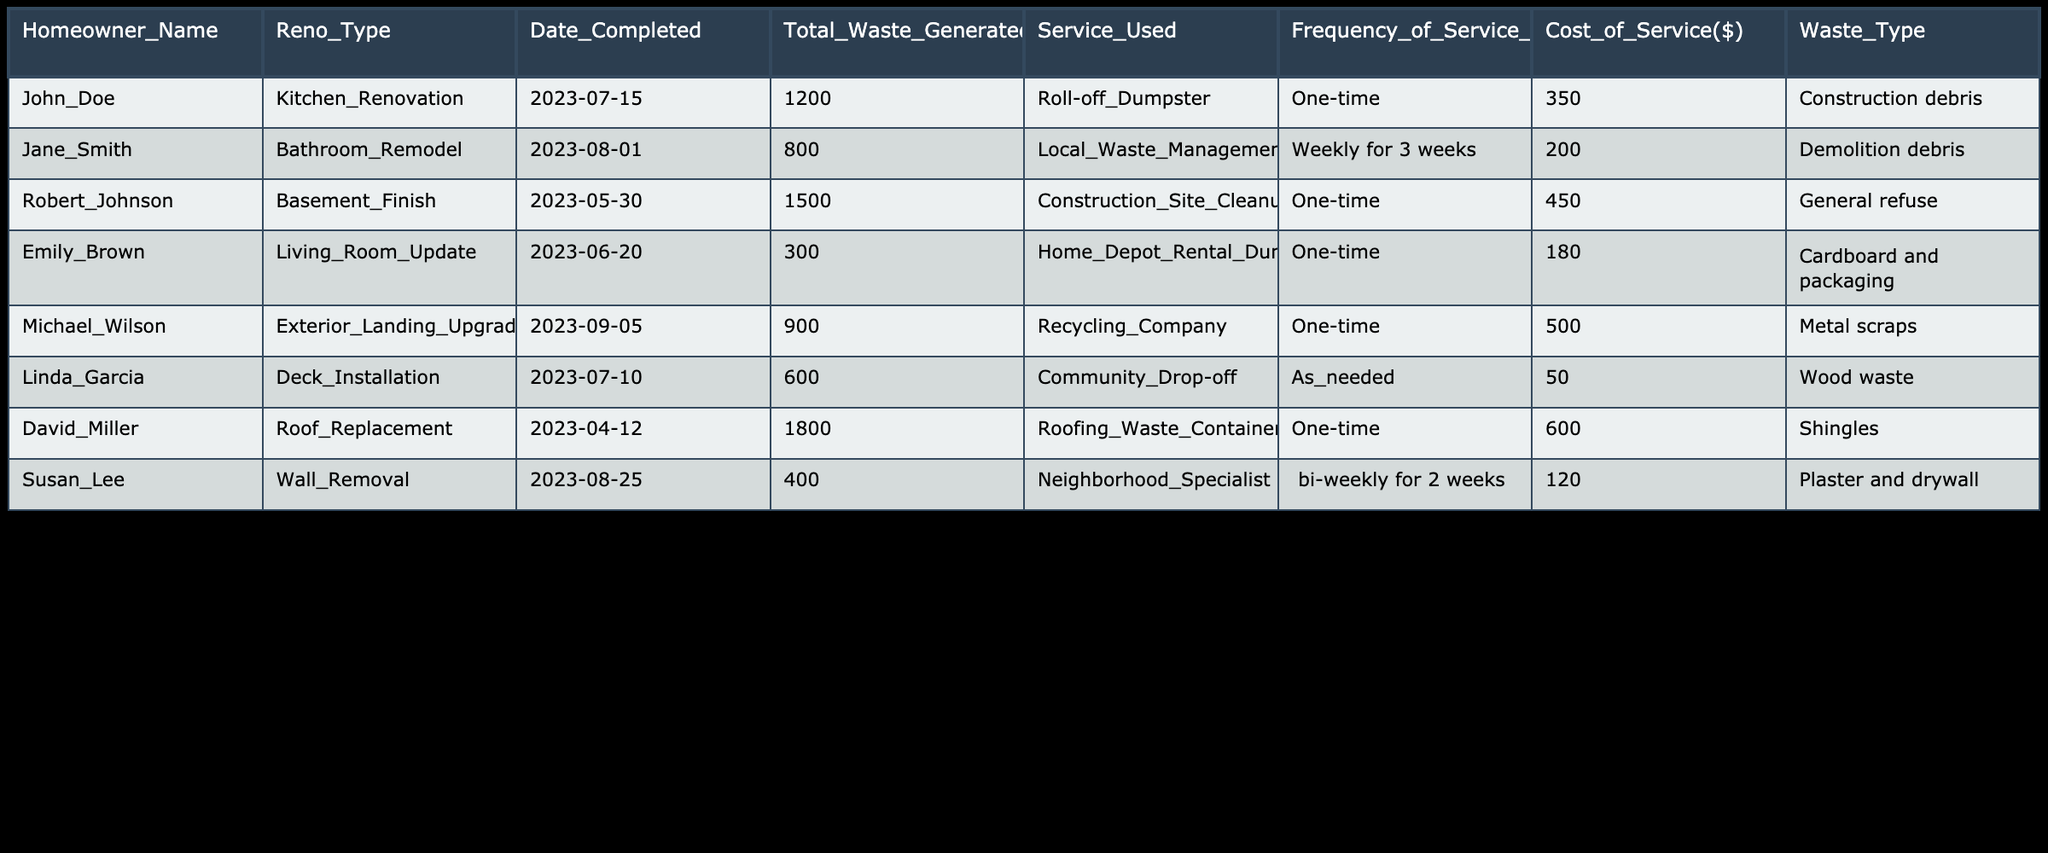What was the total waste generated by Michael Wilson? The table shows that Michael Wilson, who completed an Exterior Landing Upgrade, generated a total waste of 900 kg. This value can be directly located in the 'Total Waste Generated(kg)' column corresponding to Michael Wilson's row.
Answer: 900 kg How many homeowners utilized a one-time waste management service? By reviewing the 'Service Used' column, four homeowners (John Doe, Robert Johnson, Emily Brown, David Miller, and Michael Wilson) used a one-time service. They are indicated clearly in the corresponding rows.
Answer: 5 homeowners What is the total cost of services used by homeowners who paid over 400 dollars? The relevant homeowners who paid over 400 dollars are Robert Johnson (450), Michael Wilson (500), and David Miller (600). Summing these costs yields 450 + 500 + 600 = 1550 dollars.
Answer: 1550 dollars Did Susan Lee use a service more than once? Examining the 'Frequency of Service Used' column, it displays that Susan Lee used her service bi-weekly for two weeks, indicating that this service was utilized more than once.
Answer: Yes What type of waste management service did Linda Garcia use and how often? Linda Garcia used a Community Drop-off service on an as-needed basis, as indicated in the 'Service Used' and 'Frequency of Service Used' columns of her respective row.
Answer: Community Drop-off, as needed What is the average waste generated by homeowners who completed their renovation in June 2023? In June, two homeowners completed renovations: Emily Brown generated 300 kg and Michael Wilson generated 900 kg. Adding these together gives 300 + 900 = 1200 kg. The average would be 1200 kg / 2 = 600 kg.
Answer: 600 kg Which waste type had the highest total weight generated? By reviewing the 'Total Waste Generated(kg)' column, the highest single total is 1800 kg from David Miller’s roofing waste. This highlights that shingles resulted in the highest waste type.
Answer: Shingles, 1800 kg Is there a homeowner who used a service costing 50 dollars? Checking the 'Cost of Service($)' column, Linda Garcia is the only homeowner listed with a service cost of 50 dollars for a Community Drop-off service.
Answer: Yes 